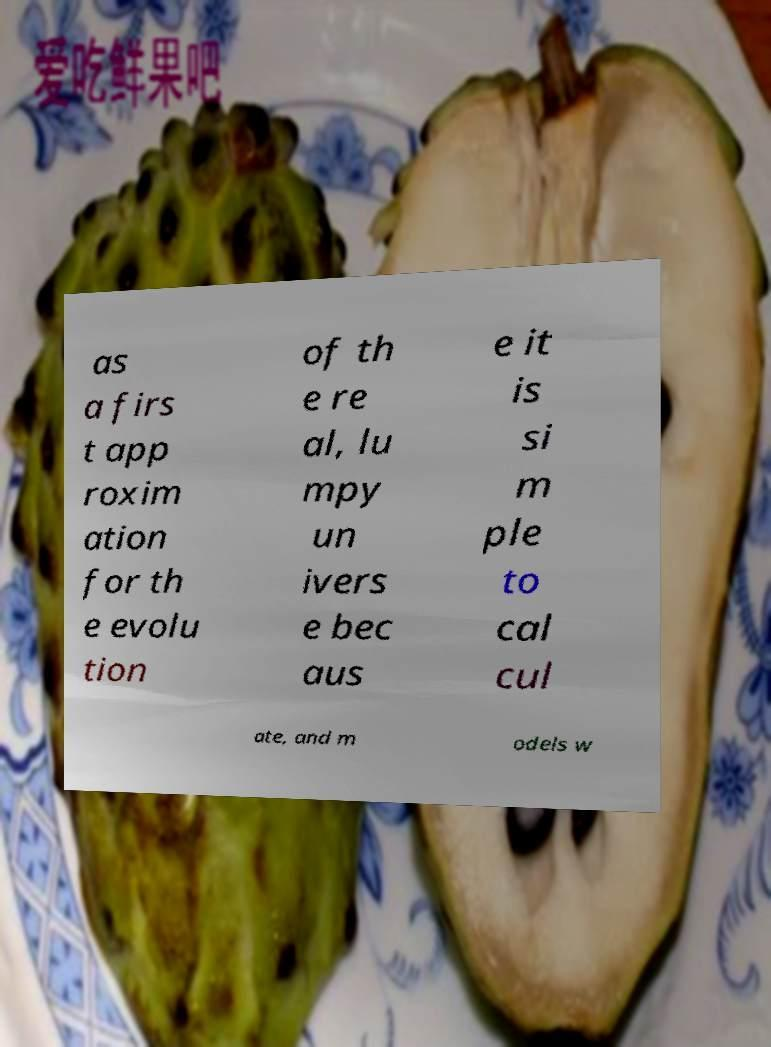For documentation purposes, I need the text within this image transcribed. Could you provide that? as a firs t app roxim ation for th e evolu tion of th e re al, lu mpy un ivers e bec aus e it is si m ple to cal cul ate, and m odels w 